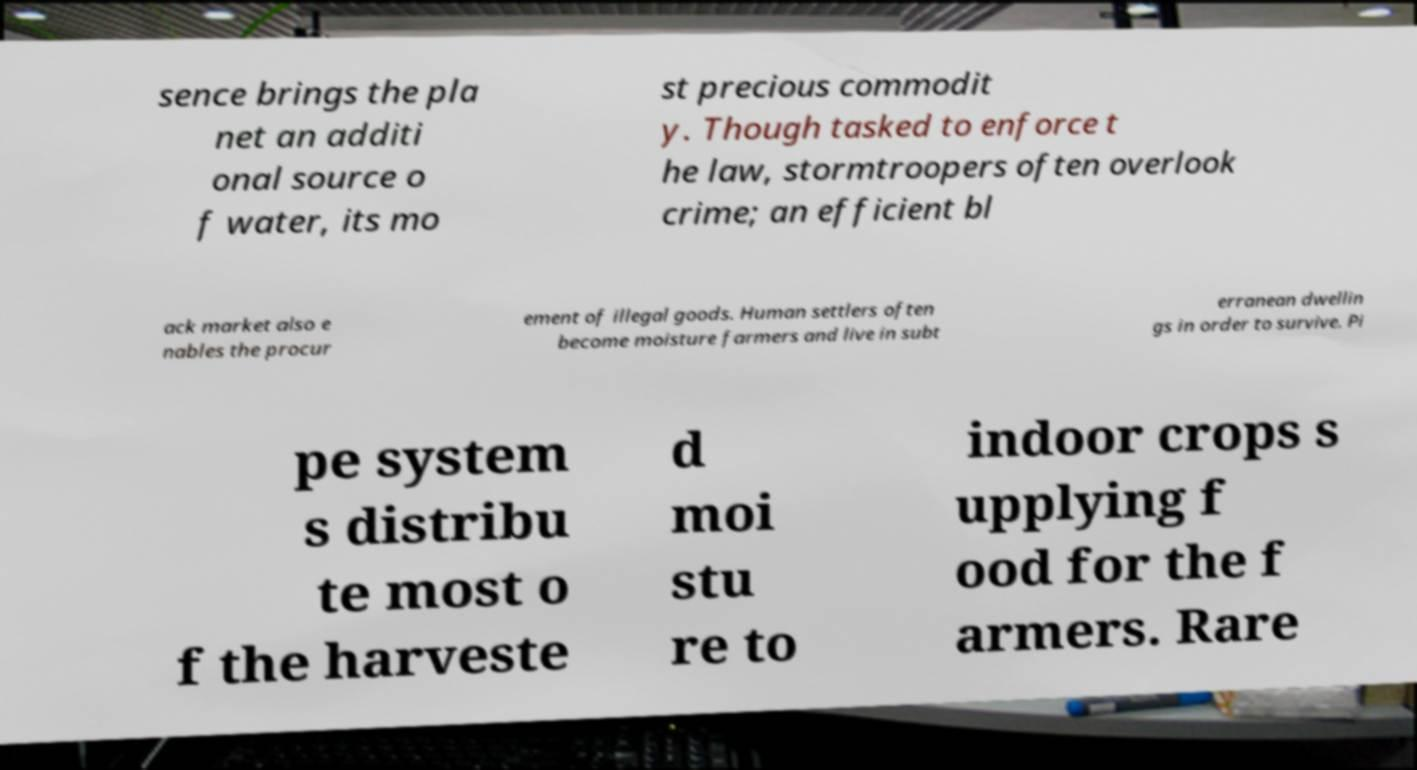What messages or text are displayed in this image? I need them in a readable, typed format. sence brings the pla net an additi onal source o f water, its mo st precious commodit y. Though tasked to enforce t he law, stormtroopers often overlook crime; an efficient bl ack market also e nables the procur ement of illegal goods. Human settlers often become moisture farmers and live in subt erranean dwellin gs in order to survive. Pi pe system s distribu te most o f the harveste d moi stu re to indoor crops s upplying f ood for the f armers. Rare 